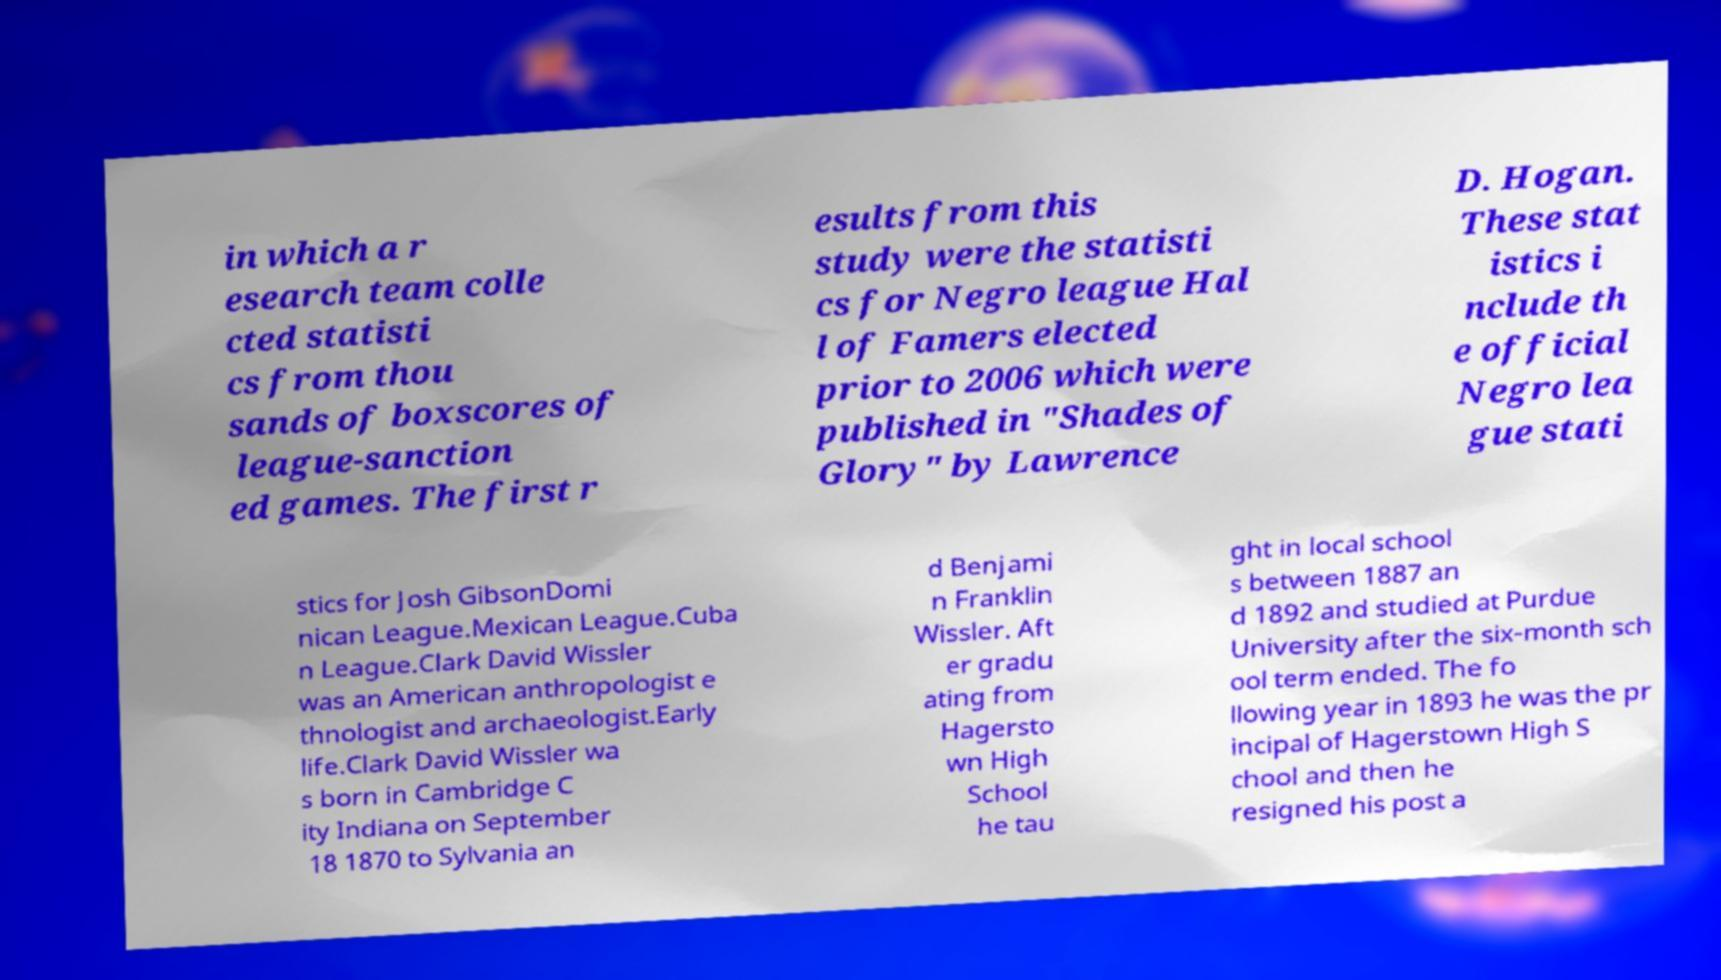Could you assist in decoding the text presented in this image and type it out clearly? in which a r esearch team colle cted statisti cs from thou sands of boxscores of league-sanction ed games. The first r esults from this study were the statisti cs for Negro league Hal l of Famers elected prior to 2006 which were published in "Shades of Glory" by Lawrence D. Hogan. These stat istics i nclude th e official Negro lea gue stati stics for Josh GibsonDomi nican League.Mexican League.Cuba n League.Clark David Wissler was an American anthropologist e thnologist and archaeologist.Early life.Clark David Wissler wa s born in Cambridge C ity Indiana on September 18 1870 to Sylvania an d Benjami n Franklin Wissler. Aft er gradu ating from Hagersto wn High School he tau ght in local school s between 1887 an d 1892 and studied at Purdue University after the six-month sch ool term ended. The fo llowing year in 1893 he was the pr incipal of Hagerstown High S chool and then he resigned his post a 